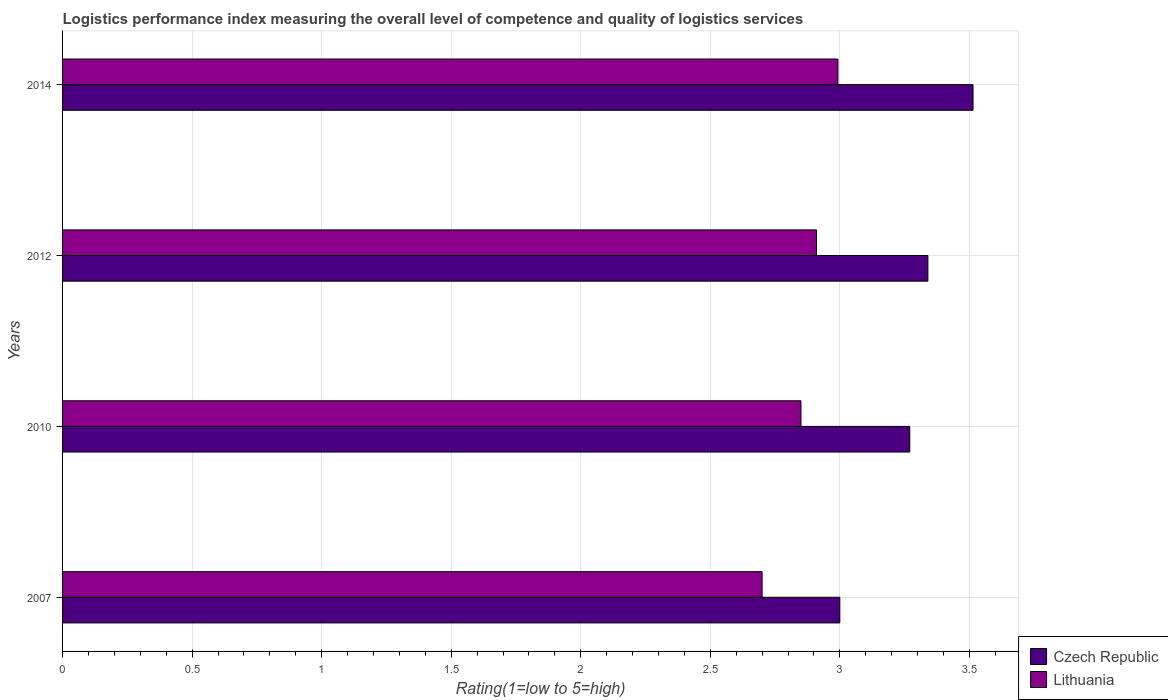How many groups of bars are there?
Offer a very short reply. 4. In how many cases, is the number of bars for a given year not equal to the number of legend labels?
Give a very brief answer. 0. What is the Logistic performance index in Czech Republic in 2010?
Provide a short and direct response. 3.27. Across all years, what is the maximum Logistic performance index in Czech Republic?
Your answer should be compact. 3.51. Across all years, what is the minimum Logistic performance index in Czech Republic?
Your answer should be very brief. 3. In which year was the Logistic performance index in Lithuania maximum?
Your answer should be compact. 2014. In which year was the Logistic performance index in Czech Republic minimum?
Ensure brevity in your answer.  2007. What is the total Logistic performance index in Lithuania in the graph?
Offer a very short reply. 11.45. What is the difference between the Logistic performance index in Czech Republic in 2007 and that in 2010?
Provide a succinct answer. -0.27. What is the difference between the Logistic performance index in Lithuania in 2010 and the Logistic performance index in Czech Republic in 2014?
Your answer should be compact. -0.66. What is the average Logistic performance index in Czech Republic per year?
Offer a very short reply. 3.28. In the year 2007, what is the difference between the Logistic performance index in Lithuania and Logistic performance index in Czech Republic?
Ensure brevity in your answer.  -0.3. What is the ratio of the Logistic performance index in Lithuania in 2010 to that in 2014?
Offer a very short reply. 0.95. Is the Logistic performance index in Czech Republic in 2007 less than that in 2010?
Your answer should be very brief. Yes. What is the difference between the highest and the second highest Logistic performance index in Lithuania?
Make the answer very short. 0.08. What is the difference between the highest and the lowest Logistic performance index in Lithuania?
Your response must be concise. 0.29. In how many years, is the Logistic performance index in Lithuania greater than the average Logistic performance index in Lithuania taken over all years?
Your response must be concise. 2. What does the 1st bar from the top in 2012 represents?
Provide a short and direct response. Lithuania. What does the 1st bar from the bottom in 2007 represents?
Offer a terse response. Czech Republic. How many years are there in the graph?
Give a very brief answer. 4. What is the difference between two consecutive major ticks on the X-axis?
Make the answer very short. 0.5. Where does the legend appear in the graph?
Your answer should be very brief. Bottom right. How many legend labels are there?
Your response must be concise. 2. How are the legend labels stacked?
Give a very brief answer. Vertical. What is the title of the graph?
Ensure brevity in your answer.  Logistics performance index measuring the overall level of competence and quality of logistics services. What is the label or title of the X-axis?
Offer a terse response. Rating(1=low to 5=high). What is the label or title of the Y-axis?
Give a very brief answer. Years. What is the Rating(1=low to 5=high) in Czech Republic in 2007?
Your answer should be compact. 3. What is the Rating(1=low to 5=high) of Czech Republic in 2010?
Keep it short and to the point. 3.27. What is the Rating(1=low to 5=high) of Lithuania in 2010?
Provide a short and direct response. 2.85. What is the Rating(1=low to 5=high) of Czech Republic in 2012?
Offer a terse response. 3.34. What is the Rating(1=low to 5=high) of Lithuania in 2012?
Your answer should be very brief. 2.91. What is the Rating(1=low to 5=high) of Czech Republic in 2014?
Your answer should be compact. 3.51. What is the Rating(1=low to 5=high) of Lithuania in 2014?
Provide a succinct answer. 2.99. Across all years, what is the maximum Rating(1=low to 5=high) in Czech Republic?
Your answer should be very brief. 3.51. Across all years, what is the maximum Rating(1=low to 5=high) in Lithuania?
Give a very brief answer. 2.99. Across all years, what is the minimum Rating(1=low to 5=high) of Lithuania?
Provide a short and direct response. 2.7. What is the total Rating(1=low to 5=high) in Czech Republic in the graph?
Give a very brief answer. 13.12. What is the total Rating(1=low to 5=high) in Lithuania in the graph?
Offer a terse response. 11.45. What is the difference between the Rating(1=low to 5=high) in Czech Republic in 2007 and that in 2010?
Your response must be concise. -0.27. What is the difference between the Rating(1=low to 5=high) in Lithuania in 2007 and that in 2010?
Make the answer very short. -0.15. What is the difference between the Rating(1=low to 5=high) in Czech Republic in 2007 and that in 2012?
Offer a very short reply. -0.34. What is the difference between the Rating(1=low to 5=high) of Lithuania in 2007 and that in 2012?
Ensure brevity in your answer.  -0.21. What is the difference between the Rating(1=low to 5=high) of Czech Republic in 2007 and that in 2014?
Your answer should be compact. -0.51. What is the difference between the Rating(1=low to 5=high) of Lithuania in 2007 and that in 2014?
Offer a terse response. -0.29. What is the difference between the Rating(1=low to 5=high) of Czech Republic in 2010 and that in 2012?
Your answer should be compact. -0.07. What is the difference between the Rating(1=low to 5=high) in Lithuania in 2010 and that in 2012?
Give a very brief answer. -0.06. What is the difference between the Rating(1=low to 5=high) of Czech Republic in 2010 and that in 2014?
Keep it short and to the point. -0.24. What is the difference between the Rating(1=low to 5=high) in Lithuania in 2010 and that in 2014?
Your response must be concise. -0.14. What is the difference between the Rating(1=low to 5=high) in Czech Republic in 2012 and that in 2014?
Provide a succinct answer. -0.17. What is the difference between the Rating(1=low to 5=high) in Lithuania in 2012 and that in 2014?
Offer a terse response. -0.08. What is the difference between the Rating(1=low to 5=high) in Czech Republic in 2007 and the Rating(1=low to 5=high) in Lithuania in 2012?
Provide a succinct answer. 0.09. What is the difference between the Rating(1=low to 5=high) of Czech Republic in 2007 and the Rating(1=low to 5=high) of Lithuania in 2014?
Ensure brevity in your answer.  0.01. What is the difference between the Rating(1=low to 5=high) in Czech Republic in 2010 and the Rating(1=low to 5=high) in Lithuania in 2012?
Keep it short and to the point. 0.36. What is the difference between the Rating(1=low to 5=high) in Czech Republic in 2010 and the Rating(1=low to 5=high) in Lithuania in 2014?
Give a very brief answer. 0.28. What is the difference between the Rating(1=low to 5=high) of Czech Republic in 2012 and the Rating(1=low to 5=high) of Lithuania in 2014?
Offer a terse response. 0.35. What is the average Rating(1=low to 5=high) of Czech Republic per year?
Give a very brief answer. 3.28. What is the average Rating(1=low to 5=high) of Lithuania per year?
Your answer should be very brief. 2.86. In the year 2007, what is the difference between the Rating(1=low to 5=high) of Czech Republic and Rating(1=low to 5=high) of Lithuania?
Make the answer very short. 0.3. In the year 2010, what is the difference between the Rating(1=low to 5=high) of Czech Republic and Rating(1=low to 5=high) of Lithuania?
Give a very brief answer. 0.42. In the year 2012, what is the difference between the Rating(1=low to 5=high) in Czech Republic and Rating(1=low to 5=high) in Lithuania?
Provide a short and direct response. 0.43. In the year 2014, what is the difference between the Rating(1=low to 5=high) in Czech Republic and Rating(1=low to 5=high) in Lithuania?
Offer a very short reply. 0.52. What is the ratio of the Rating(1=low to 5=high) of Czech Republic in 2007 to that in 2010?
Give a very brief answer. 0.92. What is the ratio of the Rating(1=low to 5=high) in Czech Republic in 2007 to that in 2012?
Make the answer very short. 0.9. What is the ratio of the Rating(1=low to 5=high) of Lithuania in 2007 to that in 2012?
Your response must be concise. 0.93. What is the ratio of the Rating(1=low to 5=high) of Czech Republic in 2007 to that in 2014?
Keep it short and to the point. 0.85. What is the ratio of the Rating(1=low to 5=high) in Lithuania in 2007 to that in 2014?
Your response must be concise. 0.9. What is the ratio of the Rating(1=low to 5=high) in Czech Republic in 2010 to that in 2012?
Your response must be concise. 0.98. What is the ratio of the Rating(1=low to 5=high) of Lithuania in 2010 to that in 2012?
Offer a very short reply. 0.98. What is the ratio of the Rating(1=low to 5=high) in Czech Republic in 2010 to that in 2014?
Offer a terse response. 0.93. What is the ratio of the Rating(1=low to 5=high) in Lithuania in 2010 to that in 2014?
Keep it short and to the point. 0.95. What is the ratio of the Rating(1=low to 5=high) of Czech Republic in 2012 to that in 2014?
Your response must be concise. 0.95. What is the ratio of the Rating(1=low to 5=high) of Lithuania in 2012 to that in 2014?
Offer a terse response. 0.97. What is the difference between the highest and the second highest Rating(1=low to 5=high) of Czech Republic?
Your response must be concise. 0.17. What is the difference between the highest and the second highest Rating(1=low to 5=high) in Lithuania?
Offer a very short reply. 0.08. What is the difference between the highest and the lowest Rating(1=low to 5=high) in Czech Republic?
Keep it short and to the point. 0.51. What is the difference between the highest and the lowest Rating(1=low to 5=high) of Lithuania?
Your answer should be very brief. 0.29. 